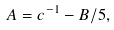<formula> <loc_0><loc_0><loc_500><loc_500>A = c ^ { - 1 } - B / 5 ,</formula> 